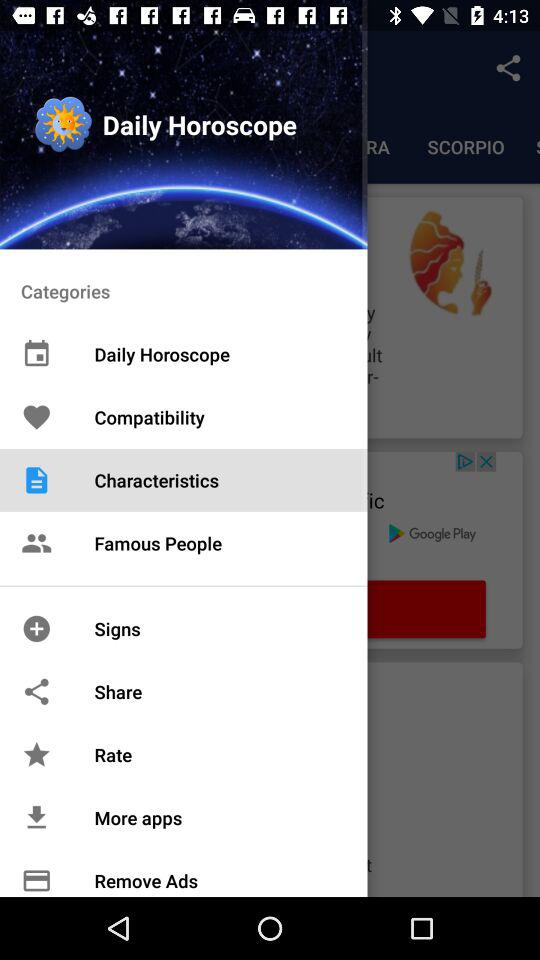Which option is selected? The selected option is Characteristics. 